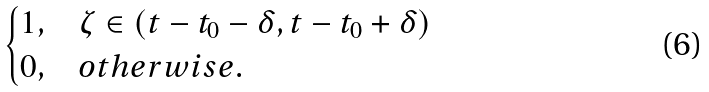<formula> <loc_0><loc_0><loc_500><loc_500>\begin{cases} 1 , & \zeta \in \left ( t - t _ { 0 } - \delta , t - t _ { 0 } + \delta \right ) \\ 0 , & o t h e r w i s e . \end{cases}</formula> 